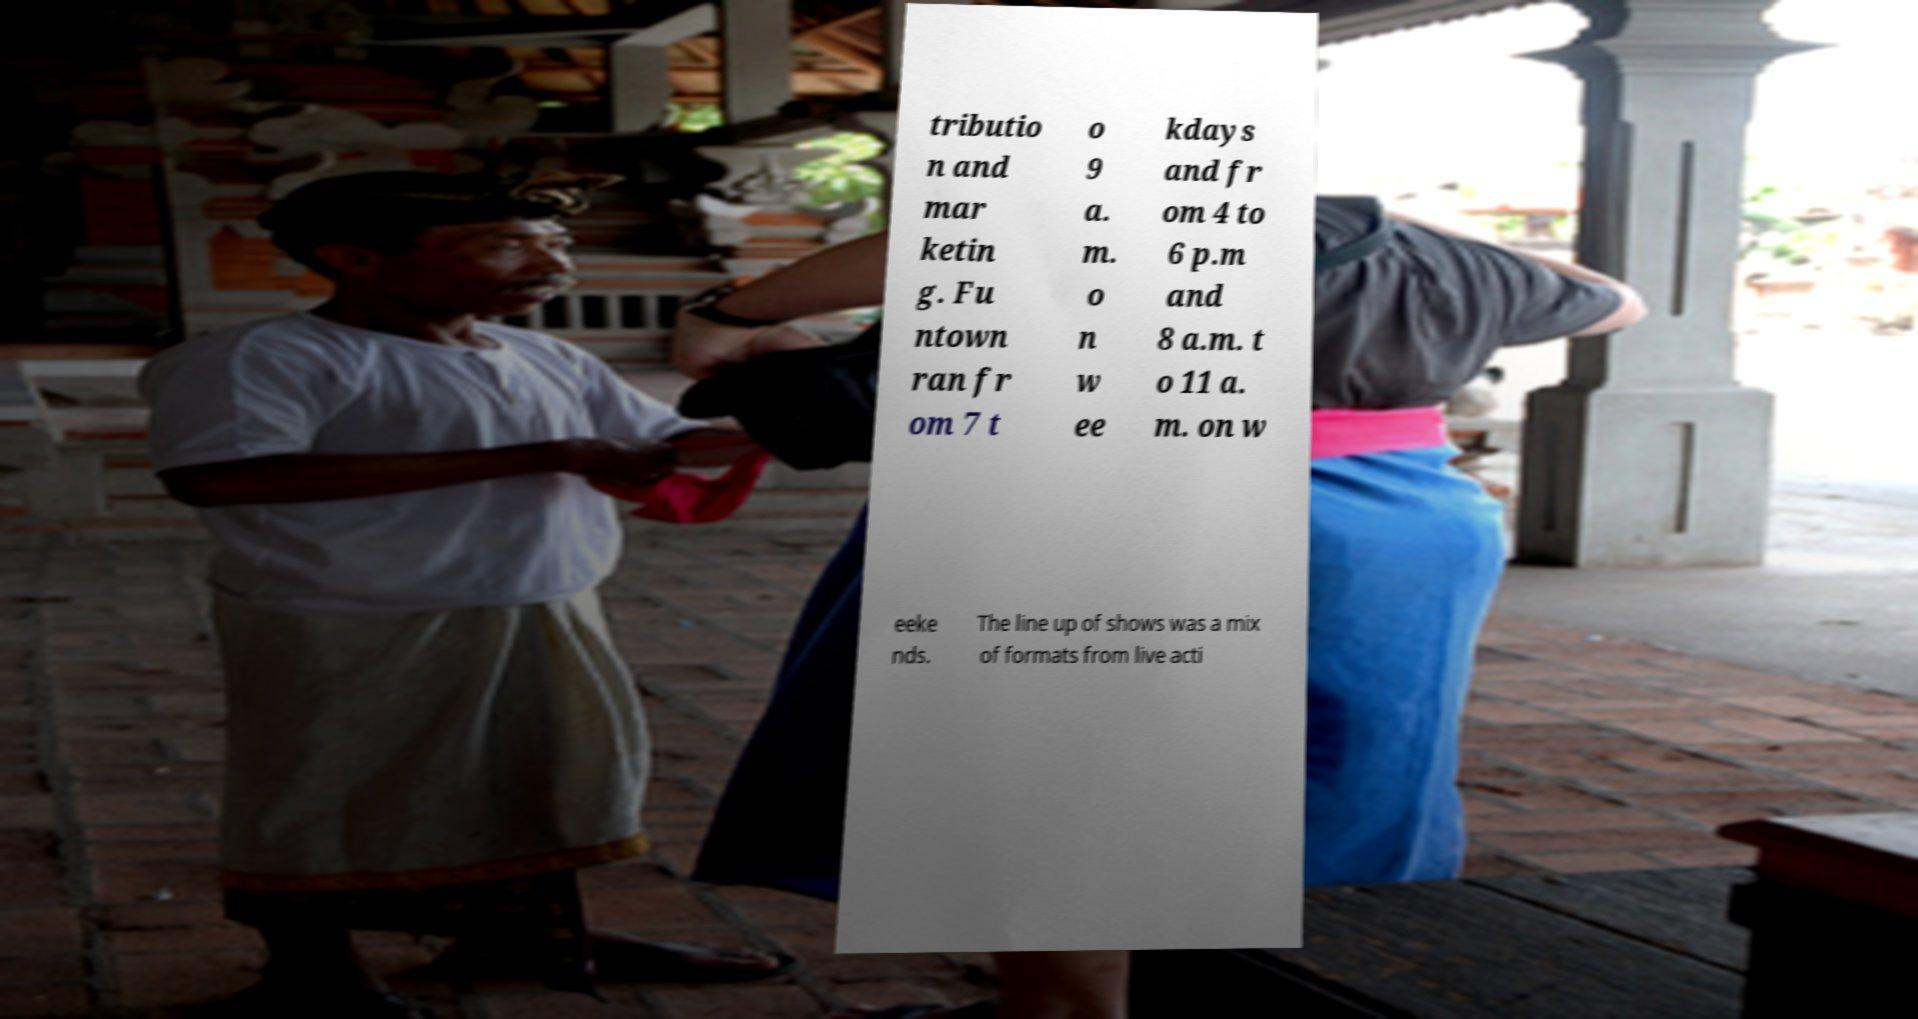Could you extract and type out the text from this image? tributio n and mar ketin g. Fu ntown ran fr om 7 t o 9 a. m. o n w ee kdays and fr om 4 to 6 p.m and 8 a.m. t o 11 a. m. on w eeke nds. The line up of shows was a mix of formats from live acti 